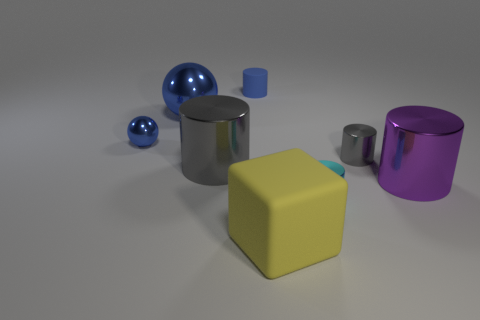Subtract 1 cylinders. How many cylinders are left? 4 Subtract all blue cylinders. How many cylinders are left? 4 Subtract all tiny gray cylinders. How many cylinders are left? 4 Subtract all purple cylinders. Subtract all green blocks. How many cylinders are left? 4 Add 1 matte cylinders. How many objects exist? 9 Subtract all spheres. How many objects are left? 6 Add 5 tiny blue rubber cylinders. How many tiny blue rubber cylinders exist? 6 Subtract 2 gray cylinders. How many objects are left? 6 Subtract all big blue metallic objects. Subtract all small objects. How many objects are left? 3 Add 8 large purple metallic cylinders. How many large purple metallic cylinders are left? 9 